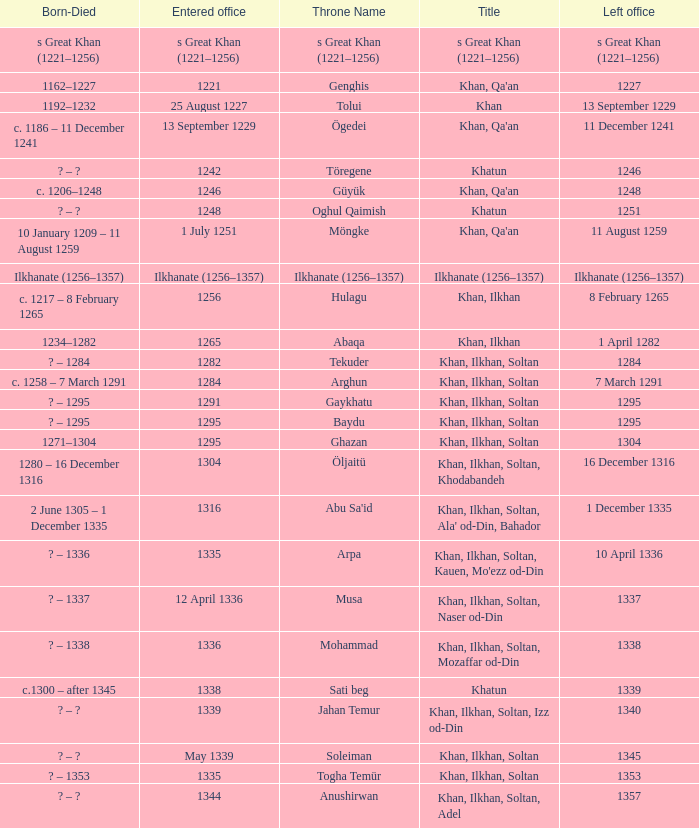What is the entered office that has 1337 as the left office? 12 April 1336. 